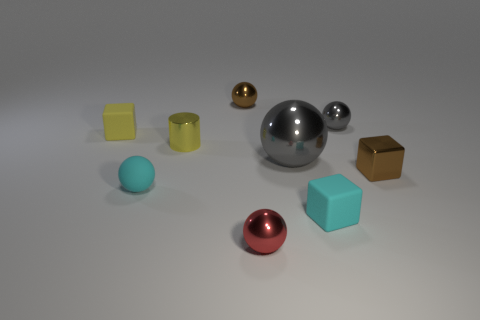The shiny ball that is the same color as the tiny metallic block is what size?
Keep it short and to the point. Small. How many tiny things are the same color as the small metallic cylinder?
Provide a short and direct response. 1. What size is the other cyan matte thing that is the same shape as the large object?
Provide a succinct answer. Small. The small cylinder has what color?
Keep it short and to the point. Yellow. What number of things are either small spheres behind the tiny gray object or small things right of the red metal ball?
Your response must be concise. 4. Does the yellow cube have the same material as the small cyan block that is to the right of the red sphere?
Your response must be concise. Yes. There is a small shiny thing that is in front of the small yellow shiny thing and on the left side of the small brown metal block; what is its shape?
Your answer should be compact. Sphere. What number of other things are the same color as the small cylinder?
Your answer should be very brief. 1. There is a big gray object; what shape is it?
Give a very brief answer. Sphere. There is a small thing that is in front of the cyan cube that is in front of the yellow shiny cylinder; what color is it?
Offer a very short reply. Red. 